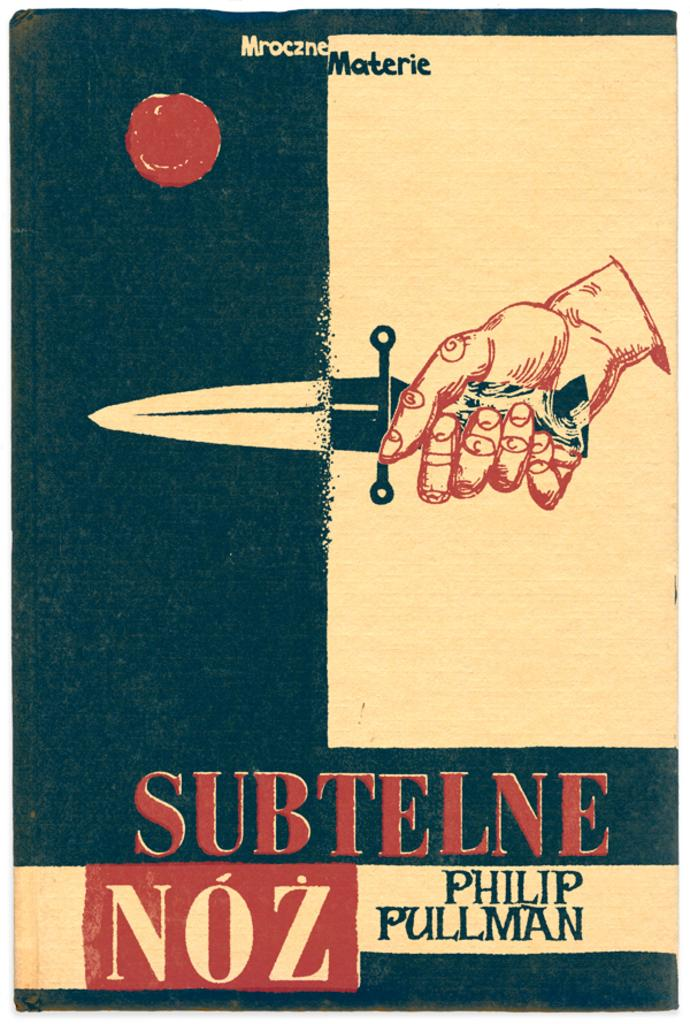Provide a one-sentence caption for the provided image. Advertising in a different language that includes a hand holding a knife or small sword. 